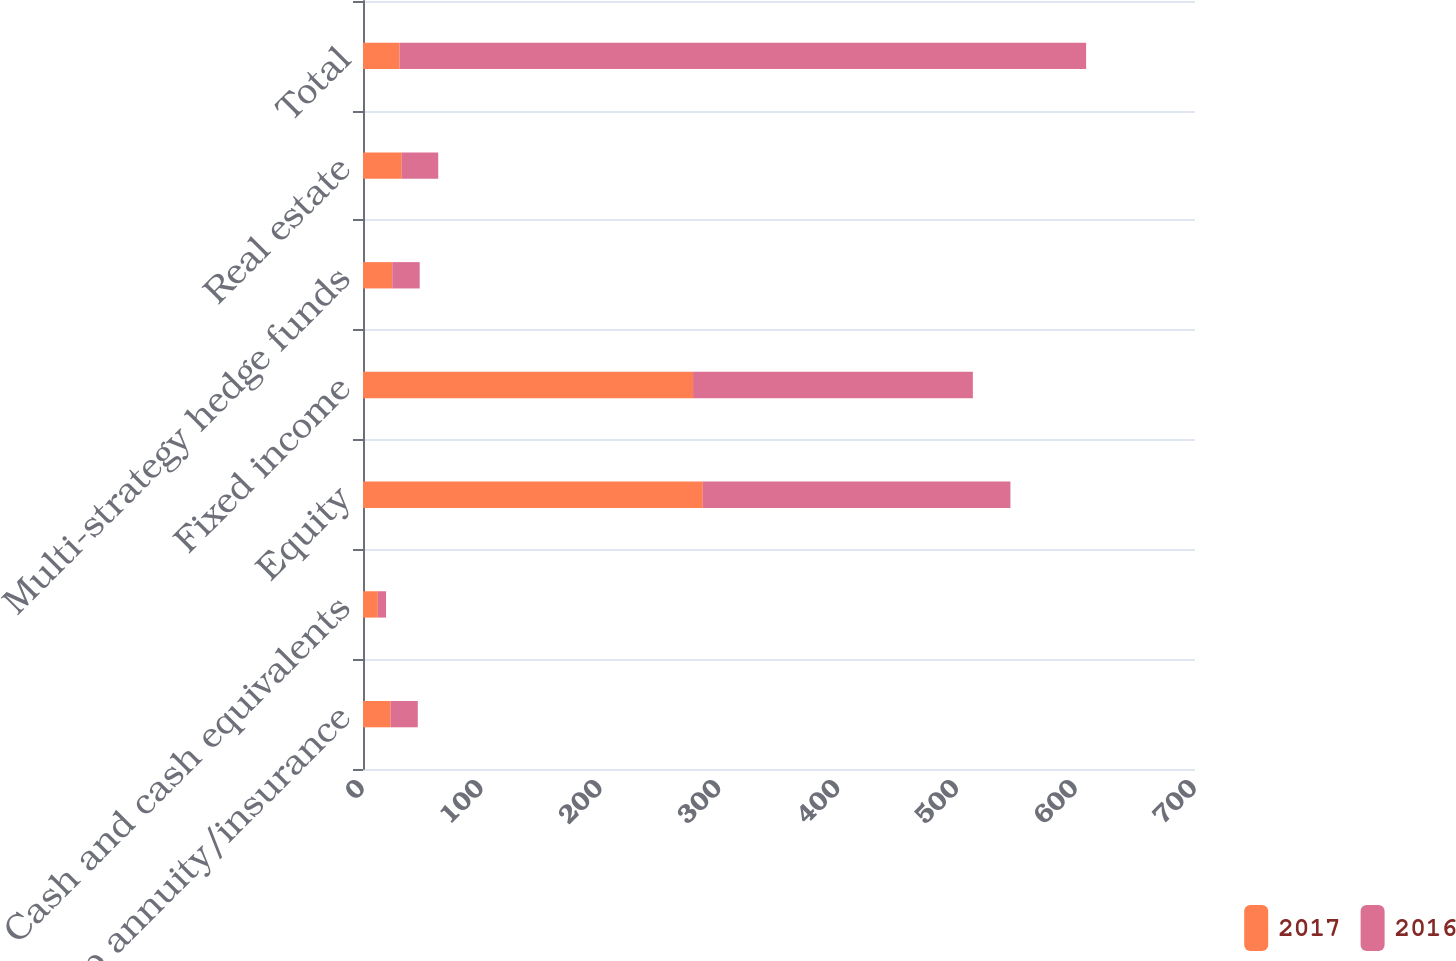Convert chart to OTSL. <chart><loc_0><loc_0><loc_500><loc_500><stacked_bar_chart><ecel><fcel>Group annuity/insurance<fcel>Cash and cash equivalents<fcel>Equity<fcel>Fixed income<fcel>Multi-strategy hedge funds<fcel>Real estate<fcel>Total<nl><fcel>2017<fcel>23.3<fcel>12.5<fcel>285.9<fcel>277.7<fcel>24.6<fcel>32.6<fcel>30.7<nl><fcel>2016<fcel>22.8<fcel>6.9<fcel>258.8<fcel>235.4<fcel>23.1<fcel>30.7<fcel>577.7<nl></chart> 